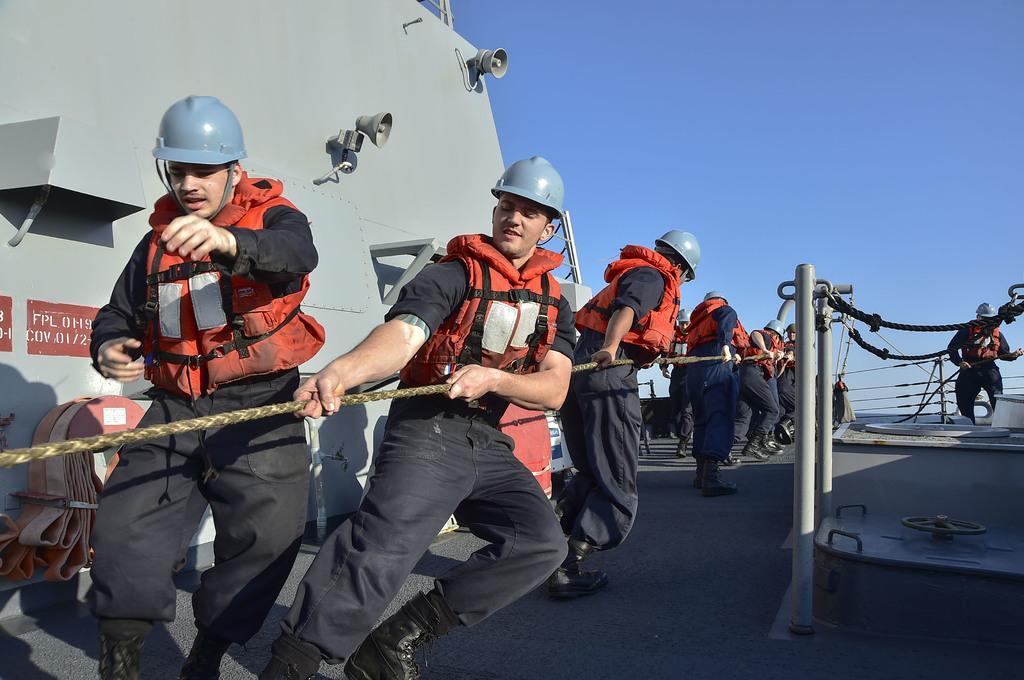Describe this image in one or two sentences. In this image in the center there are persons standing and holding rope. On the right side there is a man standing and there are ropes. On the left side there is a wall and on the wall there are mice and there is some text written on it 